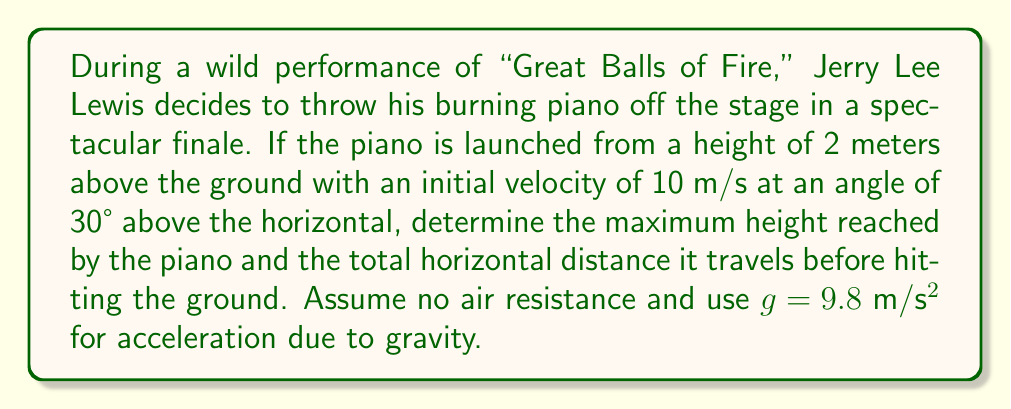Give your solution to this math problem. Let's approach this step-by-step:

1) First, we need to break down the initial velocity into its horizontal and vertical components:
   $v_x = 10 \cos(30°) = 10 \cdot \frac{\sqrt{3}}{2} = 5\sqrt{3}$ m/s
   $v_y = 10 \sin(30°) = 10 \cdot \frac{1}{2} = 5$ m/s

2) The trajectory of the piano follows a quadratic function. The general form is:
   $y = -\frac{1}{2}gt^2 + v_yt + h_0$
   where $h_0$ is the initial height (2 m in this case).

3) To find the maximum height, we need to find when the vertical velocity is zero:
   $v_y(t) = -gt + v_y = 0$
   $t = \frac{v_y}{g} = \frac{5}{9.8} \approx 0.51$ seconds

4) Plugging this time back into our quadratic function:
   $y_{max} = -\frac{1}{2}(9.8)(0.51)^2 + 5(0.51) + 2 \approx 3.28$ m

5) The maximum height reached is 3.28 m above the ground.

6) For the total horizontal distance, we need to find the time when the piano hits the ground:
   $0 = -\frac{1}{2}(9.8)t^2 + 5t + 2$
   
   Solving this quadratic equation:
   $t \approx 1.27$ seconds

7) The horizontal distance is then:
   $x = v_xt = (5\sqrt{3})(1.27) \approx 11.01$ m

Therefore, the piano reaches a maximum height of 3.28 m and travels a total horizontal distance of 11.01 m before hitting the ground.
Answer: Maximum height: 3.28 m; Horizontal distance: 11.01 m 